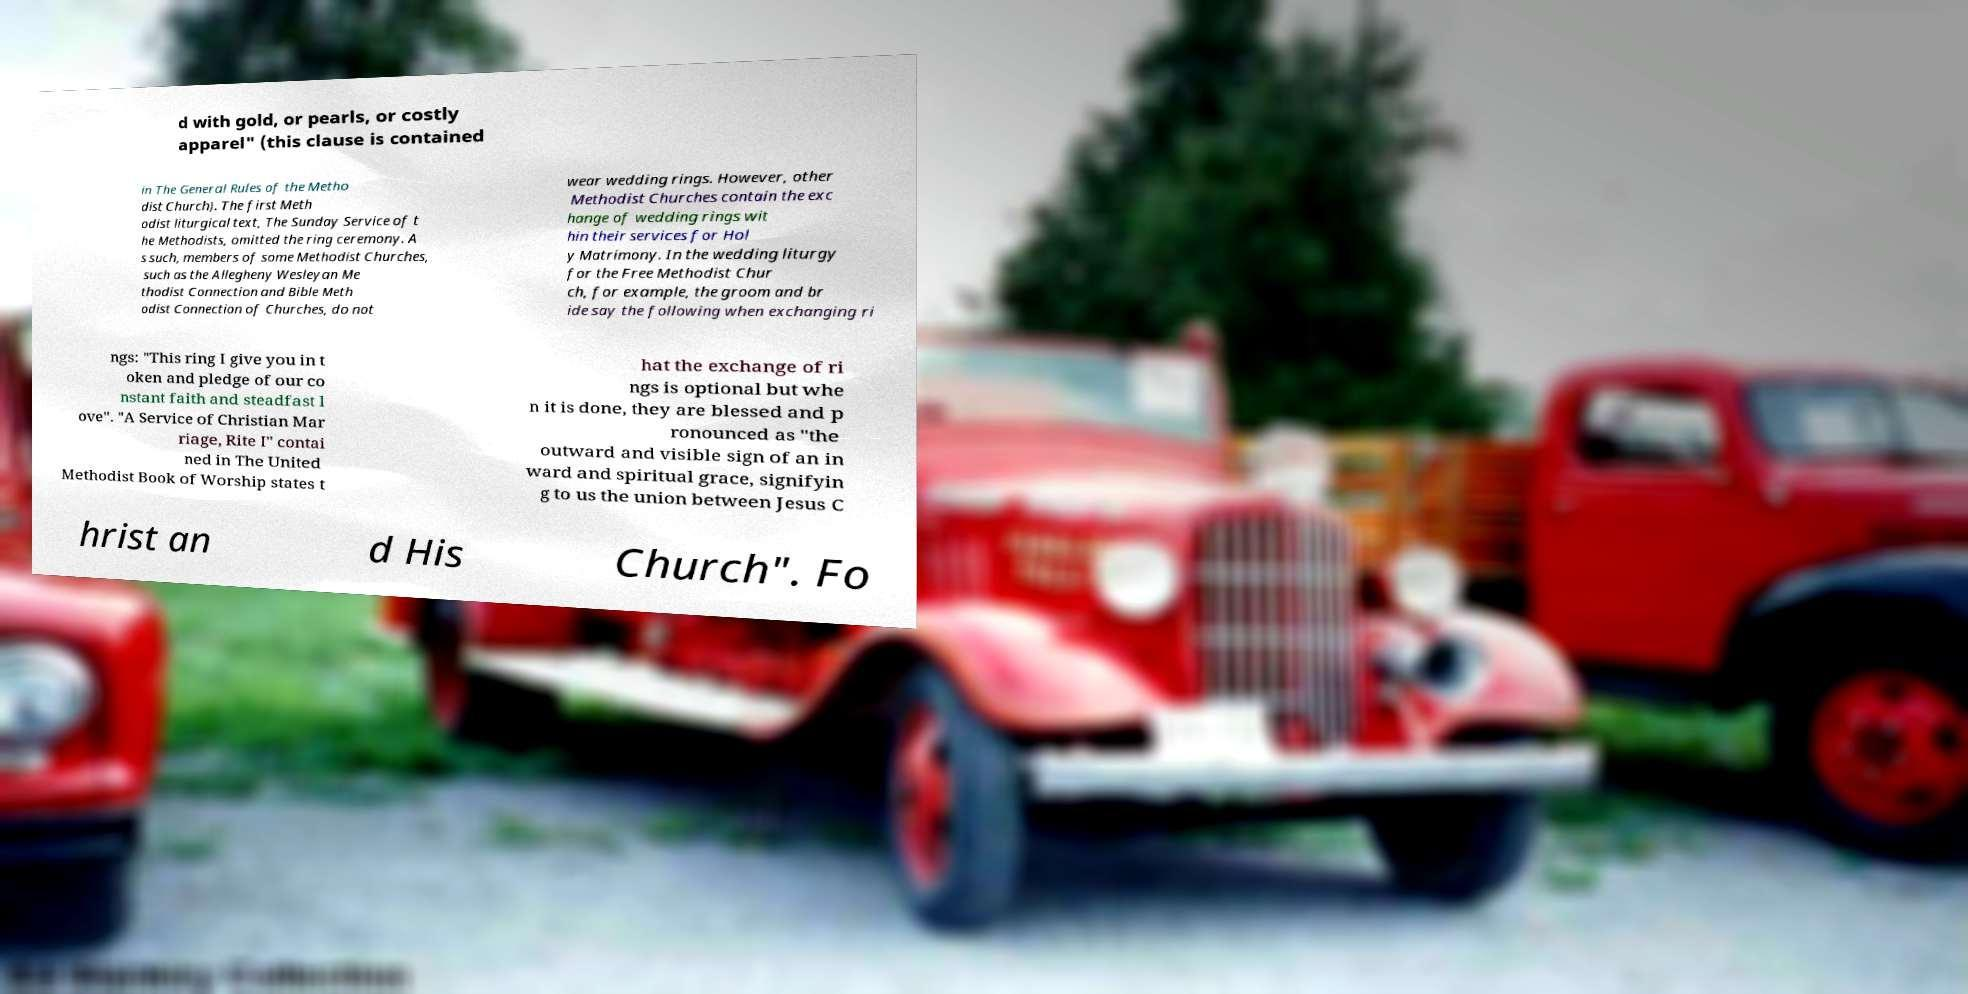I need the written content from this picture converted into text. Can you do that? d with gold, or pearls, or costly apparel" (this clause is contained in The General Rules of the Metho dist Church). The first Meth odist liturgical text, The Sunday Service of t he Methodists, omitted the ring ceremony. A s such, members of some Methodist Churches, such as the Allegheny Wesleyan Me thodist Connection and Bible Meth odist Connection of Churches, do not wear wedding rings. However, other Methodist Churches contain the exc hange of wedding rings wit hin their services for Hol y Matrimony. In the wedding liturgy for the Free Methodist Chur ch, for example, the groom and br ide say the following when exchanging ri ngs: "This ring I give you in t oken and pledge of our co nstant faith and steadfast l ove". "A Service of Christian Mar riage, Rite I" contai ned in The United Methodist Book of Worship states t hat the exchange of ri ngs is optional but whe n it is done, they are blessed and p ronounced as "the outward and visible sign of an in ward and spiritual grace, signifyin g to us the union between Jesus C hrist an d His Church". Fo 